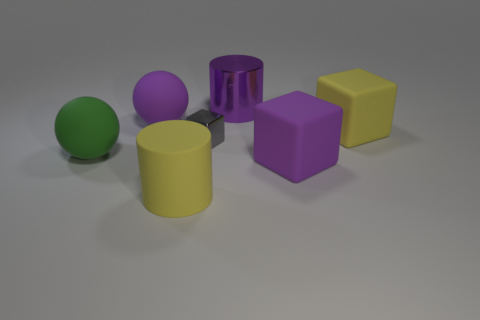What number of blocks are tiny gray objects or large gray rubber objects?
Offer a terse response. 1. There is a big purple thing on the left side of the large purple metal cylinder; what is its material?
Provide a short and direct response. Rubber. Are there fewer small blue metal cubes than purple things?
Ensure brevity in your answer.  Yes. What size is the purple object that is both in front of the large purple metallic thing and on the right side of the purple rubber sphere?
Your answer should be very brief. Large. What size is the yellow rubber thing that is in front of the large yellow rubber object that is behind the yellow matte object that is to the left of the purple cube?
Your response must be concise. Large. How many other things are the same color as the large metallic object?
Ensure brevity in your answer.  2. There is a cylinder on the left side of the purple metallic thing; is it the same color as the large shiny thing?
Provide a succinct answer. No. How many things are large balls or metal things?
Your response must be concise. 4. There is a matte sphere behind the big green object; what color is it?
Make the answer very short. Purple. Are there fewer yellow objects left of the metallic block than big blue things?
Your answer should be compact. No. 